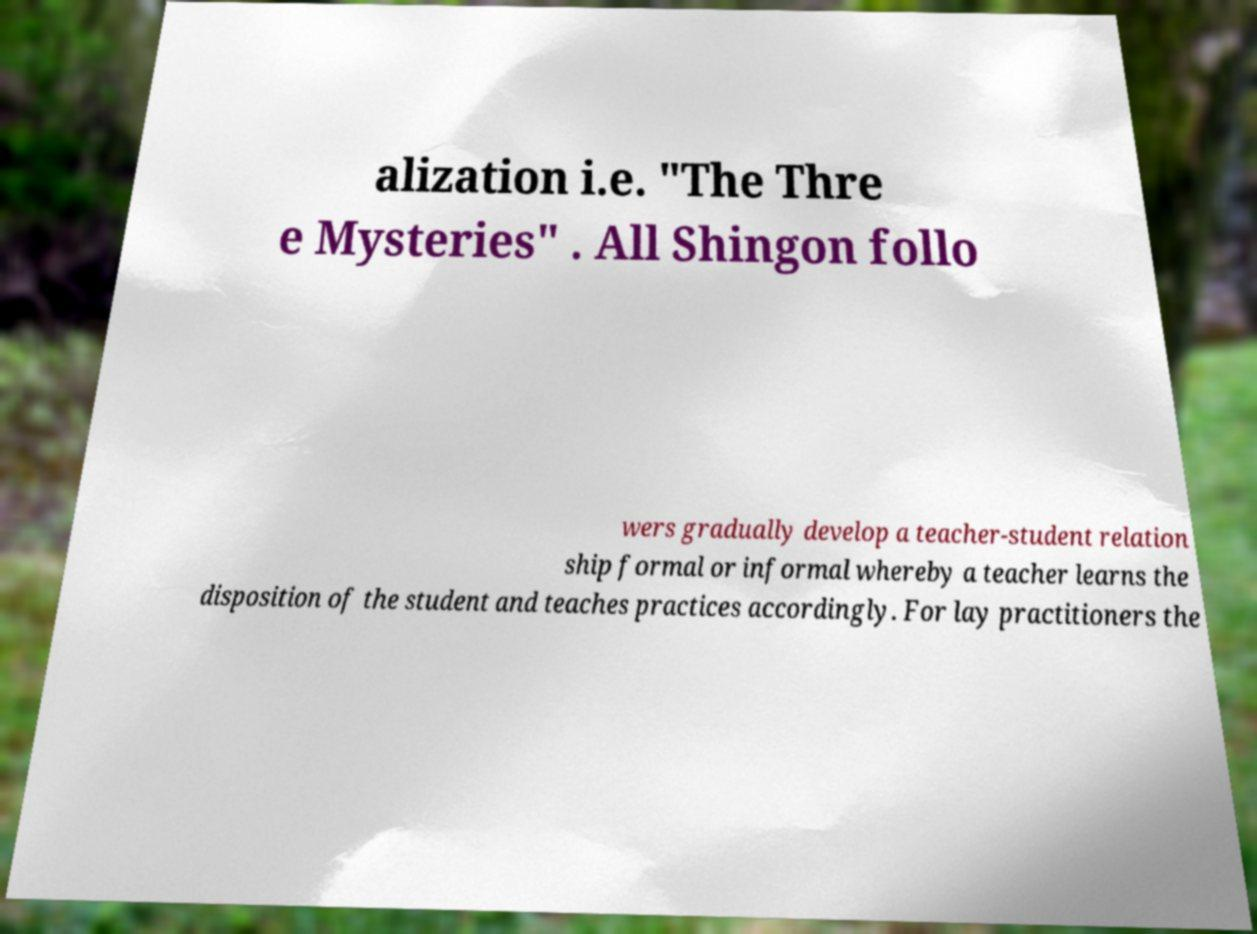Can you accurately transcribe the text from the provided image for me? alization i.e. "The Thre e Mysteries" . All Shingon follo wers gradually develop a teacher-student relation ship formal or informal whereby a teacher learns the disposition of the student and teaches practices accordingly. For lay practitioners the 